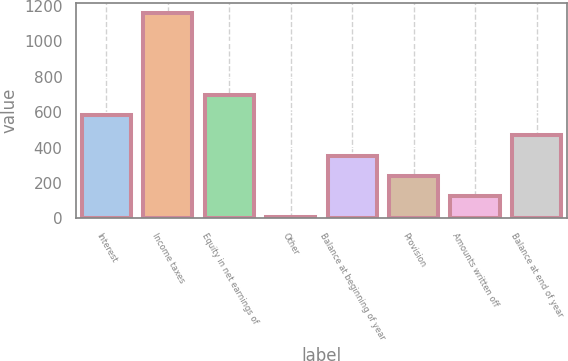Convert chart to OTSL. <chart><loc_0><loc_0><loc_500><loc_500><bar_chart><fcel>Interest<fcel>Income taxes<fcel>Equity in net earnings of<fcel>Other<fcel>Balance at beginning of year<fcel>Provision<fcel>Amounts written off<fcel>Balance at end of year<nl><fcel>584<fcel>1158<fcel>698.8<fcel>10<fcel>354.4<fcel>239.6<fcel>124.8<fcel>469.2<nl></chart> 